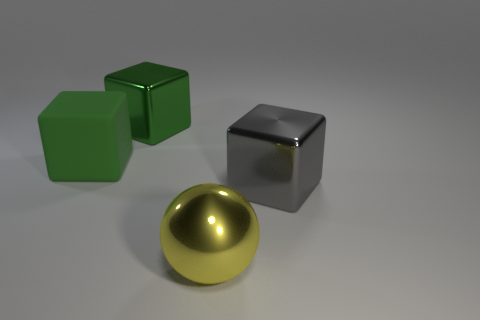Add 2 gray things. How many objects exist? 6 Subtract all cubes. How many objects are left? 1 Add 3 large yellow metal objects. How many large yellow metal objects exist? 4 Subtract 1 yellow spheres. How many objects are left? 3 Subtract all green metallic blocks. Subtract all big green blocks. How many objects are left? 1 Add 3 green shiny things. How many green shiny things are left? 4 